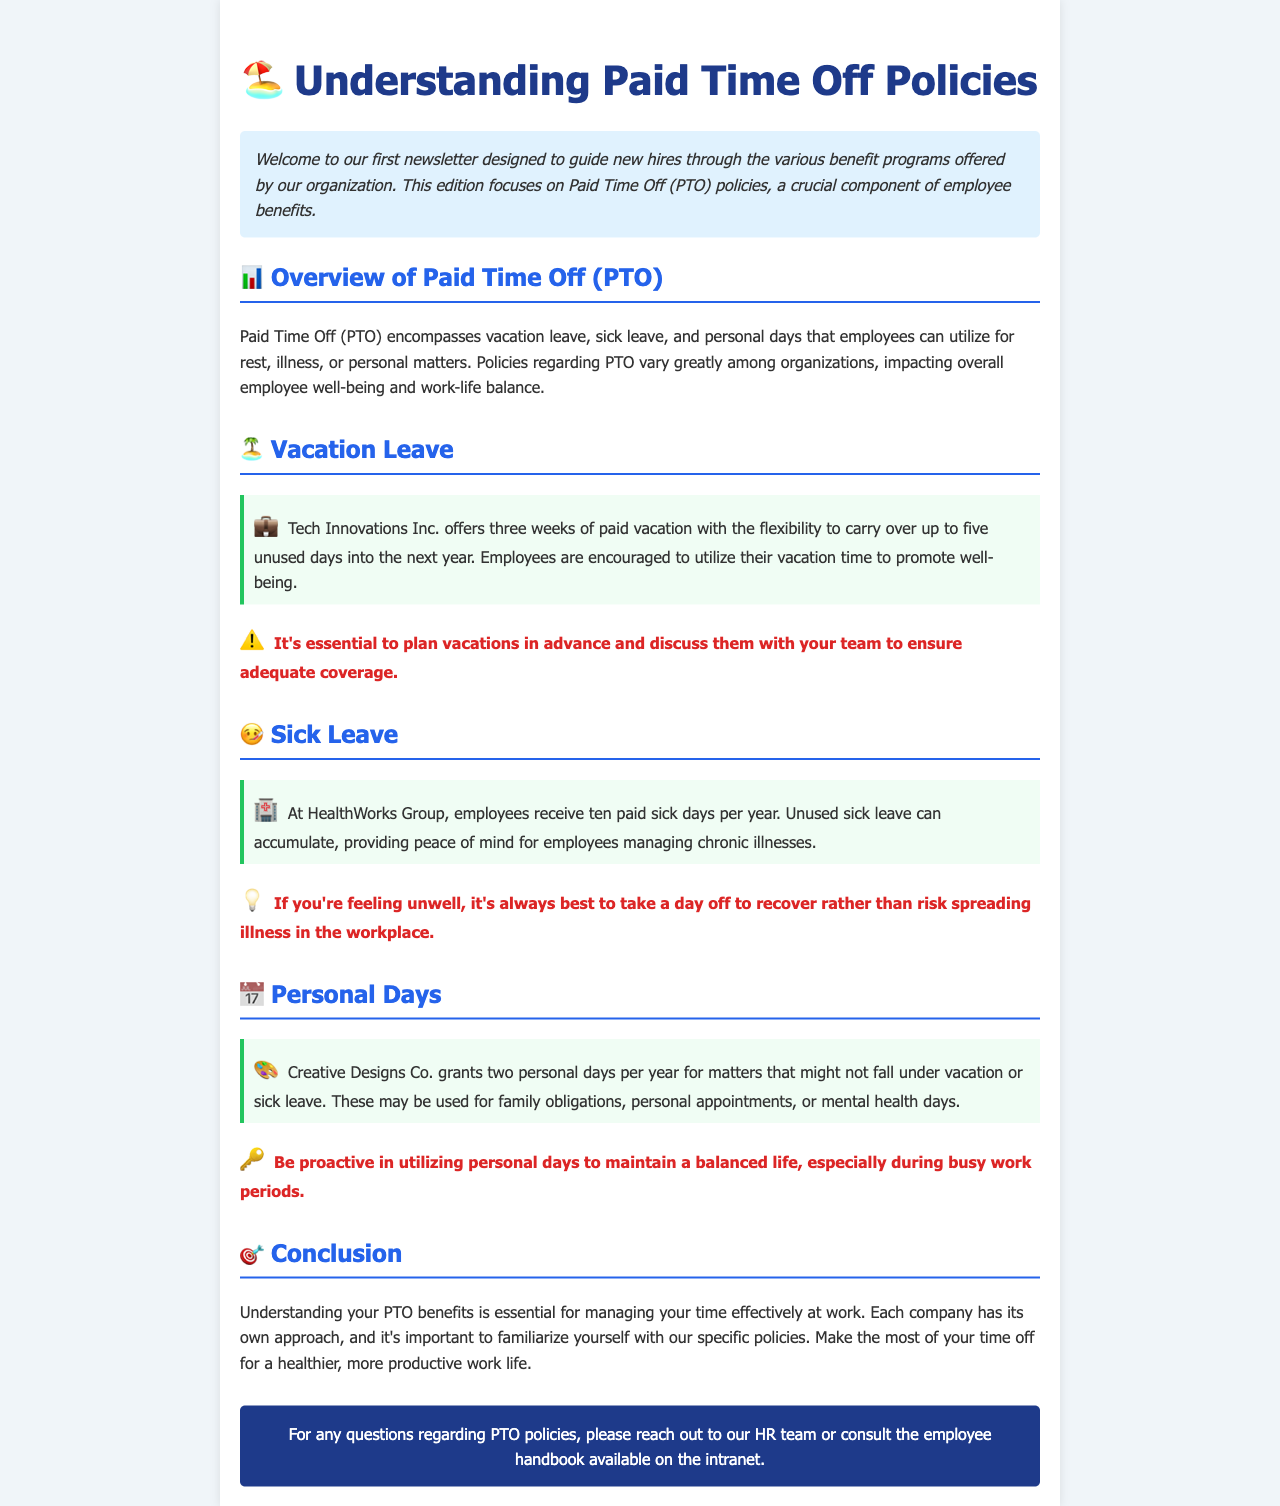What is the title of the newsletter? The title of the newsletter is presented prominently at the top, stating its focus on PTO policies.
Answer: Understanding Paid Time Off Policies How many weeks of paid vacation does Tech Innovations Inc. offer? The document specifies that Tech Innovations Inc. provides three weeks of paid vacation.
Answer: three weeks What is the maximum number of unused vacation days that can be carried over? The text indicates that up to five unused vacation days can be carried over into the next year.
Answer: five days How many sick days do employees receive at HealthWorks Group? The document outlines that employees at HealthWorks Group receive ten paid sick days per year.
Answer: ten days What is the purpose of the two personal days granted by Creative Designs Co.? The section on personal days explains their purpose for matters not covered by vacation or sick leave, such as family obligations.
Answer: family obligations What’s one reason for taking sick leave mentioned in the document? The reasoning provided suggests taking a day off to recover rather than risk spreading illness in the workplace.
Answer: recover What is emphasized as important for utilizing vacation time? The document urges employees to plan vacations in advance and discuss them with their team for adequate coverage.
Answer: plan in advance What is a key tip for personal days? The newsletter suggests being proactive in utilizing personal days to maintain life balance.
Answer: be proactive What is the role of the HR team mentioned at the end of the document? The document highlights that the HR team can assist with questions regarding PTO policies.
Answer: assist with questions 